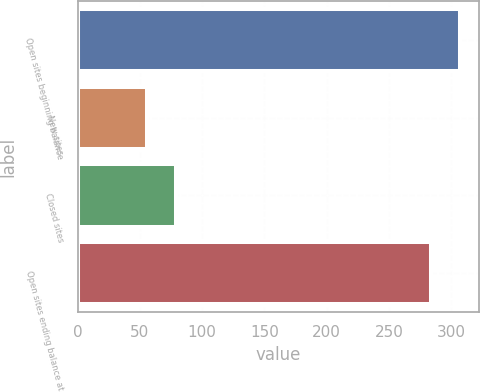Convert chart. <chart><loc_0><loc_0><loc_500><loc_500><bar_chart><fcel>Open sites beginning balance<fcel>New sites<fcel>Closed sites<fcel>Open sites ending balance at<nl><fcel>306.9<fcel>56<fcel>78.9<fcel>284<nl></chart> 